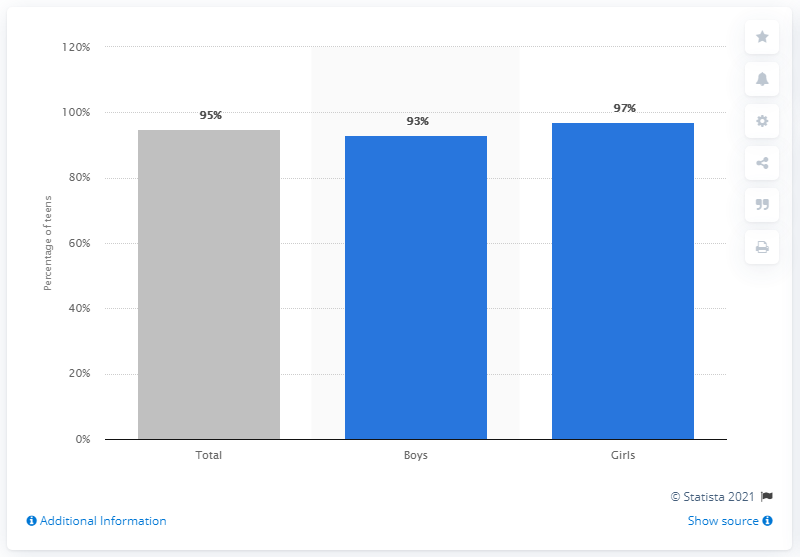Outline some significant characteristics in this image. According to the data, the smartphone access rate for teens between the ages of 13 and 17 was 93%. 